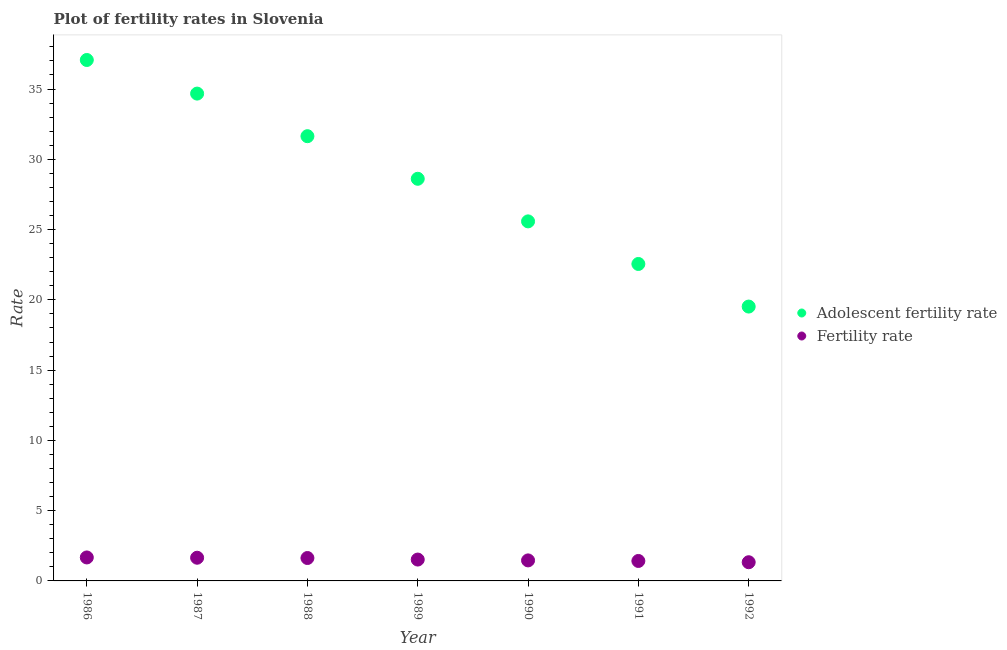How many different coloured dotlines are there?
Give a very brief answer. 2. What is the fertility rate in 1992?
Provide a short and direct response. 1.33. Across all years, what is the maximum fertility rate?
Keep it short and to the point. 1.67. Across all years, what is the minimum adolescent fertility rate?
Keep it short and to the point. 19.52. In which year was the adolescent fertility rate minimum?
Ensure brevity in your answer.  1992. What is the total adolescent fertility rate in the graph?
Ensure brevity in your answer.  199.66. What is the difference between the fertility rate in 1986 and that in 1991?
Offer a very short reply. 0.25. What is the difference between the adolescent fertility rate in 1988 and the fertility rate in 1990?
Keep it short and to the point. 30.19. What is the average fertility rate per year?
Keep it short and to the point. 1.53. In the year 1991, what is the difference between the adolescent fertility rate and fertility rate?
Make the answer very short. 21.13. In how many years, is the fertility rate greater than 18?
Provide a succinct answer. 0. What is the ratio of the adolescent fertility rate in 1987 to that in 1992?
Provide a succinct answer. 1.78. What is the difference between the highest and the second highest adolescent fertility rate?
Keep it short and to the point. 2.39. What is the difference between the highest and the lowest adolescent fertility rate?
Make the answer very short. 17.55. Is the fertility rate strictly greater than the adolescent fertility rate over the years?
Your answer should be very brief. No. How many years are there in the graph?
Ensure brevity in your answer.  7. Does the graph contain any zero values?
Your response must be concise. No. How many legend labels are there?
Provide a short and direct response. 2. What is the title of the graph?
Provide a short and direct response. Plot of fertility rates in Slovenia. What is the label or title of the X-axis?
Your answer should be very brief. Year. What is the label or title of the Y-axis?
Your answer should be compact. Rate. What is the Rate of Adolescent fertility rate in 1986?
Your response must be concise. 37.07. What is the Rate in Fertility rate in 1986?
Offer a very short reply. 1.67. What is the Rate in Adolescent fertility rate in 1987?
Your answer should be compact. 34.68. What is the Rate of Fertility rate in 1987?
Offer a very short reply. 1.65. What is the Rate in Adolescent fertility rate in 1988?
Your answer should be compact. 31.65. What is the Rate in Fertility rate in 1988?
Provide a succinct answer. 1.63. What is the Rate of Adolescent fertility rate in 1989?
Offer a very short reply. 28.61. What is the Rate in Fertility rate in 1989?
Your answer should be compact. 1.52. What is the Rate of Adolescent fertility rate in 1990?
Ensure brevity in your answer.  25.58. What is the Rate of Fertility rate in 1990?
Your response must be concise. 1.46. What is the Rate in Adolescent fertility rate in 1991?
Make the answer very short. 22.55. What is the Rate in Fertility rate in 1991?
Your answer should be compact. 1.42. What is the Rate in Adolescent fertility rate in 1992?
Your answer should be very brief. 19.52. What is the Rate in Fertility rate in 1992?
Your answer should be very brief. 1.33. Across all years, what is the maximum Rate of Adolescent fertility rate?
Your response must be concise. 37.07. Across all years, what is the maximum Rate of Fertility rate?
Provide a succinct answer. 1.67. Across all years, what is the minimum Rate of Adolescent fertility rate?
Offer a terse response. 19.52. Across all years, what is the minimum Rate of Fertility rate?
Your response must be concise. 1.33. What is the total Rate in Adolescent fertility rate in the graph?
Ensure brevity in your answer.  199.66. What is the total Rate in Fertility rate in the graph?
Provide a short and direct response. 10.68. What is the difference between the Rate in Adolescent fertility rate in 1986 and that in 1987?
Offer a very short reply. 2.39. What is the difference between the Rate in Adolescent fertility rate in 1986 and that in 1988?
Keep it short and to the point. 5.42. What is the difference between the Rate of Fertility rate in 1986 and that in 1988?
Provide a short and direct response. 0.04. What is the difference between the Rate in Adolescent fertility rate in 1986 and that in 1989?
Your answer should be very brief. 8.45. What is the difference between the Rate of Fertility rate in 1986 and that in 1989?
Your response must be concise. 0.15. What is the difference between the Rate of Adolescent fertility rate in 1986 and that in 1990?
Your response must be concise. 11.48. What is the difference between the Rate of Fertility rate in 1986 and that in 1990?
Provide a succinct answer. 0.21. What is the difference between the Rate of Adolescent fertility rate in 1986 and that in 1991?
Keep it short and to the point. 14.51. What is the difference between the Rate of Adolescent fertility rate in 1986 and that in 1992?
Your answer should be very brief. 17.55. What is the difference between the Rate of Fertility rate in 1986 and that in 1992?
Keep it short and to the point. 0.34. What is the difference between the Rate of Adolescent fertility rate in 1987 and that in 1988?
Ensure brevity in your answer.  3.03. What is the difference between the Rate in Fertility rate in 1987 and that in 1988?
Provide a succinct answer. 0.02. What is the difference between the Rate of Adolescent fertility rate in 1987 and that in 1989?
Your response must be concise. 6.06. What is the difference between the Rate in Fertility rate in 1987 and that in 1989?
Provide a short and direct response. 0.13. What is the difference between the Rate of Adolescent fertility rate in 1987 and that in 1990?
Give a very brief answer. 9.09. What is the difference between the Rate of Fertility rate in 1987 and that in 1990?
Offer a terse response. 0.19. What is the difference between the Rate of Adolescent fertility rate in 1987 and that in 1991?
Your answer should be very brief. 12.12. What is the difference between the Rate of Fertility rate in 1987 and that in 1991?
Offer a terse response. 0.23. What is the difference between the Rate of Adolescent fertility rate in 1987 and that in 1992?
Provide a succinct answer. 15.15. What is the difference between the Rate in Fertility rate in 1987 and that in 1992?
Offer a terse response. 0.32. What is the difference between the Rate in Adolescent fertility rate in 1988 and that in 1989?
Offer a very short reply. 3.03. What is the difference between the Rate in Fertility rate in 1988 and that in 1989?
Your answer should be very brief. 0.11. What is the difference between the Rate in Adolescent fertility rate in 1988 and that in 1990?
Make the answer very short. 6.06. What is the difference between the Rate of Fertility rate in 1988 and that in 1990?
Give a very brief answer. 0.17. What is the difference between the Rate of Adolescent fertility rate in 1988 and that in 1991?
Your answer should be very brief. 9.09. What is the difference between the Rate of Fertility rate in 1988 and that in 1991?
Make the answer very short. 0.21. What is the difference between the Rate in Adolescent fertility rate in 1988 and that in 1992?
Give a very brief answer. 12.12. What is the difference between the Rate of Fertility rate in 1988 and that in 1992?
Your answer should be compact. 0.3. What is the difference between the Rate in Adolescent fertility rate in 1989 and that in 1990?
Your answer should be compact. 3.03. What is the difference between the Rate in Adolescent fertility rate in 1989 and that in 1991?
Offer a terse response. 6.06. What is the difference between the Rate of Adolescent fertility rate in 1989 and that in 1992?
Give a very brief answer. 9.09. What is the difference between the Rate in Fertility rate in 1989 and that in 1992?
Your response must be concise. 0.19. What is the difference between the Rate in Adolescent fertility rate in 1990 and that in 1991?
Provide a short and direct response. 3.03. What is the difference between the Rate in Adolescent fertility rate in 1990 and that in 1992?
Offer a terse response. 6.06. What is the difference between the Rate of Fertility rate in 1990 and that in 1992?
Your answer should be compact. 0.13. What is the difference between the Rate of Adolescent fertility rate in 1991 and that in 1992?
Keep it short and to the point. 3.03. What is the difference between the Rate in Fertility rate in 1991 and that in 1992?
Give a very brief answer. 0.09. What is the difference between the Rate in Adolescent fertility rate in 1986 and the Rate in Fertility rate in 1987?
Give a very brief answer. 35.42. What is the difference between the Rate in Adolescent fertility rate in 1986 and the Rate in Fertility rate in 1988?
Your answer should be compact. 35.44. What is the difference between the Rate of Adolescent fertility rate in 1986 and the Rate of Fertility rate in 1989?
Ensure brevity in your answer.  35.55. What is the difference between the Rate in Adolescent fertility rate in 1986 and the Rate in Fertility rate in 1990?
Your answer should be very brief. 35.61. What is the difference between the Rate of Adolescent fertility rate in 1986 and the Rate of Fertility rate in 1991?
Provide a short and direct response. 35.65. What is the difference between the Rate in Adolescent fertility rate in 1986 and the Rate in Fertility rate in 1992?
Ensure brevity in your answer.  35.74. What is the difference between the Rate of Adolescent fertility rate in 1987 and the Rate of Fertility rate in 1988?
Provide a succinct answer. 33.05. What is the difference between the Rate in Adolescent fertility rate in 1987 and the Rate in Fertility rate in 1989?
Keep it short and to the point. 33.16. What is the difference between the Rate in Adolescent fertility rate in 1987 and the Rate in Fertility rate in 1990?
Offer a very short reply. 33.22. What is the difference between the Rate of Adolescent fertility rate in 1987 and the Rate of Fertility rate in 1991?
Offer a terse response. 33.26. What is the difference between the Rate of Adolescent fertility rate in 1987 and the Rate of Fertility rate in 1992?
Your answer should be very brief. 33.35. What is the difference between the Rate of Adolescent fertility rate in 1988 and the Rate of Fertility rate in 1989?
Your response must be concise. 30.13. What is the difference between the Rate of Adolescent fertility rate in 1988 and the Rate of Fertility rate in 1990?
Your answer should be very brief. 30.19. What is the difference between the Rate in Adolescent fertility rate in 1988 and the Rate in Fertility rate in 1991?
Provide a succinct answer. 30.23. What is the difference between the Rate of Adolescent fertility rate in 1988 and the Rate of Fertility rate in 1992?
Your answer should be very brief. 30.32. What is the difference between the Rate of Adolescent fertility rate in 1989 and the Rate of Fertility rate in 1990?
Give a very brief answer. 27.15. What is the difference between the Rate of Adolescent fertility rate in 1989 and the Rate of Fertility rate in 1991?
Make the answer very short. 27.19. What is the difference between the Rate of Adolescent fertility rate in 1989 and the Rate of Fertility rate in 1992?
Make the answer very short. 27.28. What is the difference between the Rate in Adolescent fertility rate in 1990 and the Rate in Fertility rate in 1991?
Your answer should be compact. 24.16. What is the difference between the Rate of Adolescent fertility rate in 1990 and the Rate of Fertility rate in 1992?
Provide a succinct answer. 24.25. What is the difference between the Rate in Adolescent fertility rate in 1991 and the Rate in Fertility rate in 1992?
Make the answer very short. 21.22. What is the average Rate in Adolescent fertility rate per year?
Keep it short and to the point. 28.52. What is the average Rate in Fertility rate per year?
Offer a very short reply. 1.53. In the year 1986, what is the difference between the Rate of Adolescent fertility rate and Rate of Fertility rate?
Offer a very short reply. 35.4. In the year 1987, what is the difference between the Rate of Adolescent fertility rate and Rate of Fertility rate?
Provide a succinct answer. 33.03. In the year 1988, what is the difference between the Rate of Adolescent fertility rate and Rate of Fertility rate?
Offer a terse response. 30.02. In the year 1989, what is the difference between the Rate of Adolescent fertility rate and Rate of Fertility rate?
Provide a short and direct response. 27.09. In the year 1990, what is the difference between the Rate of Adolescent fertility rate and Rate of Fertility rate?
Provide a succinct answer. 24.12. In the year 1991, what is the difference between the Rate in Adolescent fertility rate and Rate in Fertility rate?
Your response must be concise. 21.13. In the year 1992, what is the difference between the Rate of Adolescent fertility rate and Rate of Fertility rate?
Your answer should be very brief. 18.19. What is the ratio of the Rate of Adolescent fertility rate in 1986 to that in 1987?
Give a very brief answer. 1.07. What is the ratio of the Rate in Fertility rate in 1986 to that in 1987?
Keep it short and to the point. 1.01. What is the ratio of the Rate in Adolescent fertility rate in 1986 to that in 1988?
Provide a succinct answer. 1.17. What is the ratio of the Rate of Fertility rate in 1986 to that in 1988?
Offer a very short reply. 1.02. What is the ratio of the Rate of Adolescent fertility rate in 1986 to that in 1989?
Provide a succinct answer. 1.3. What is the ratio of the Rate in Fertility rate in 1986 to that in 1989?
Give a very brief answer. 1.1. What is the ratio of the Rate of Adolescent fertility rate in 1986 to that in 1990?
Keep it short and to the point. 1.45. What is the ratio of the Rate of Fertility rate in 1986 to that in 1990?
Offer a terse response. 1.14. What is the ratio of the Rate in Adolescent fertility rate in 1986 to that in 1991?
Provide a succinct answer. 1.64. What is the ratio of the Rate in Fertility rate in 1986 to that in 1991?
Your response must be concise. 1.18. What is the ratio of the Rate of Adolescent fertility rate in 1986 to that in 1992?
Provide a succinct answer. 1.9. What is the ratio of the Rate in Fertility rate in 1986 to that in 1992?
Keep it short and to the point. 1.26. What is the ratio of the Rate of Adolescent fertility rate in 1987 to that in 1988?
Make the answer very short. 1.1. What is the ratio of the Rate in Fertility rate in 1987 to that in 1988?
Offer a terse response. 1.01. What is the ratio of the Rate in Adolescent fertility rate in 1987 to that in 1989?
Offer a very short reply. 1.21. What is the ratio of the Rate in Fertility rate in 1987 to that in 1989?
Give a very brief answer. 1.09. What is the ratio of the Rate of Adolescent fertility rate in 1987 to that in 1990?
Offer a very short reply. 1.36. What is the ratio of the Rate in Fertility rate in 1987 to that in 1990?
Make the answer very short. 1.13. What is the ratio of the Rate in Adolescent fertility rate in 1987 to that in 1991?
Offer a very short reply. 1.54. What is the ratio of the Rate in Fertility rate in 1987 to that in 1991?
Keep it short and to the point. 1.16. What is the ratio of the Rate in Adolescent fertility rate in 1987 to that in 1992?
Provide a succinct answer. 1.78. What is the ratio of the Rate in Fertility rate in 1987 to that in 1992?
Your answer should be very brief. 1.24. What is the ratio of the Rate of Adolescent fertility rate in 1988 to that in 1989?
Ensure brevity in your answer.  1.11. What is the ratio of the Rate of Fertility rate in 1988 to that in 1989?
Make the answer very short. 1.07. What is the ratio of the Rate in Adolescent fertility rate in 1988 to that in 1990?
Your answer should be very brief. 1.24. What is the ratio of the Rate in Fertility rate in 1988 to that in 1990?
Your answer should be very brief. 1.12. What is the ratio of the Rate in Adolescent fertility rate in 1988 to that in 1991?
Offer a terse response. 1.4. What is the ratio of the Rate in Fertility rate in 1988 to that in 1991?
Offer a very short reply. 1.15. What is the ratio of the Rate in Adolescent fertility rate in 1988 to that in 1992?
Give a very brief answer. 1.62. What is the ratio of the Rate of Fertility rate in 1988 to that in 1992?
Make the answer very short. 1.23. What is the ratio of the Rate of Adolescent fertility rate in 1989 to that in 1990?
Offer a very short reply. 1.12. What is the ratio of the Rate of Fertility rate in 1989 to that in 1990?
Ensure brevity in your answer.  1.04. What is the ratio of the Rate of Adolescent fertility rate in 1989 to that in 1991?
Provide a short and direct response. 1.27. What is the ratio of the Rate in Fertility rate in 1989 to that in 1991?
Your answer should be compact. 1.07. What is the ratio of the Rate in Adolescent fertility rate in 1989 to that in 1992?
Your response must be concise. 1.47. What is the ratio of the Rate of Adolescent fertility rate in 1990 to that in 1991?
Your answer should be very brief. 1.13. What is the ratio of the Rate in Fertility rate in 1990 to that in 1991?
Your answer should be compact. 1.03. What is the ratio of the Rate of Adolescent fertility rate in 1990 to that in 1992?
Ensure brevity in your answer.  1.31. What is the ratio of the Rate in Fertility rate in 1990 to that in 1992?
Provide a short and direct response. 1.1. What is the ratio of the Rate in Adolescent fertility rate in 1991 to that in 1992?
Ensure brevity in your answer.  1.16. What is the ratio of the Rate of Fertility rate in 1991 to that in 1992?
Give a very brief answer. 1.07. What is the difference between the highest and the second highest Rate of Adolescent fertility rate?
Your response must be concise. 2.39. What is the difference between the highest and the second highest Rate in Fertility rate?
Your answer should be compact. 0.02. What is the difference between the highest and the lowest Rate in Adolescent fertility rate?
Offer a terse response. 17.55. What is the difference between the highest and the lowest Rate in Fertility rate?
Offer a very short reply. 0.34. 